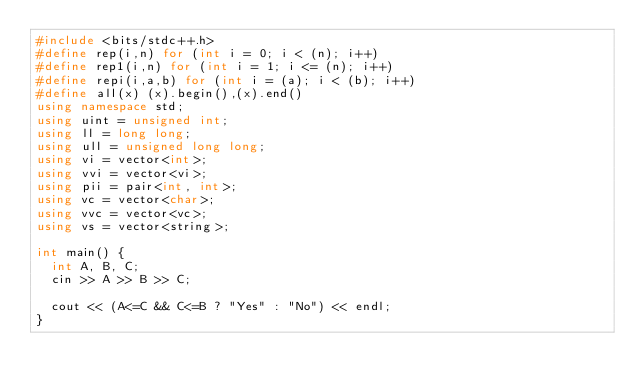Convert code to text. <code><loc_0><loc_0><loc_500><loc_500><_C++_>#include <bits/stdc++.h>
#define rep(i,n) for (int i = 0; i < (n); i++)
#define rep1(i,n) for (int i = 1; i <= (n); i++)
#define repi(i,a,b) for (int i = (a); i < (b); i++)
#define all(x) (x).begin(),(x).end()
using namespace std;
using uint = unsigned int;
using ll = long long;
using ull = unsigned long long;
using vi = vector<int>;
using vvi = vector<vi>;
using pii = pair<int, int>;
using vc = vector<char>;
using vvc = vector<vc>;
using vs = vector<string>;

int main() {
  int A, B, C;
  cin >> A >> B >> C;
  
  cout << (A<=C && C<=B ? "Yes" : "No") << endl;
}</code> 